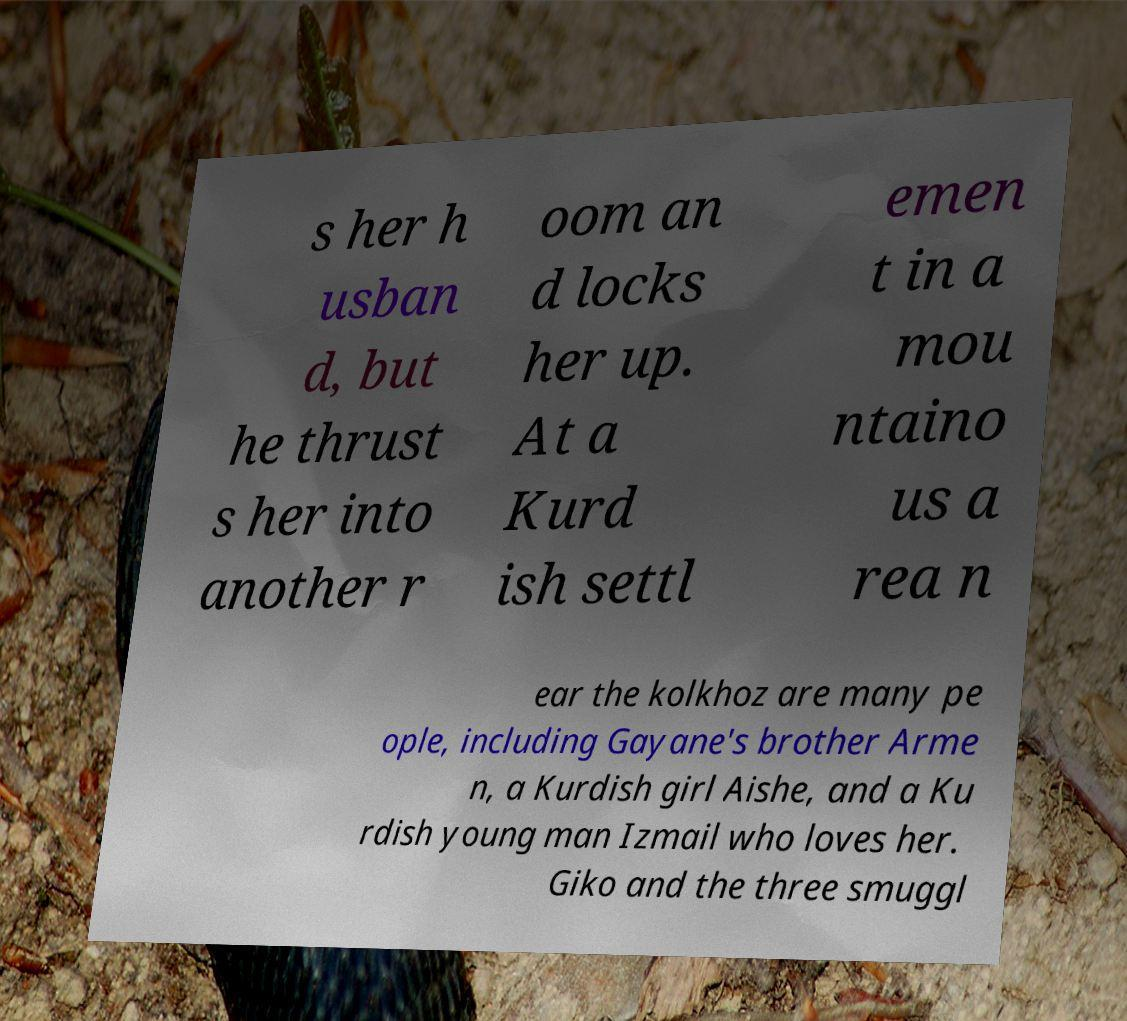Could you assist in decoding the text presented in this image and type it out clearly? s her h usban d, but he thrust s her into another r oom an d locks her up. At a Kurd ish settl emen t in a mou ntaino us a rea n ear the kolkhoz are many pe ople, including Gayane's brother Arme n, a Kurdish girl Aishe, and a Ku rdish young man Izmail who loves her. Giko and the three smuggl 